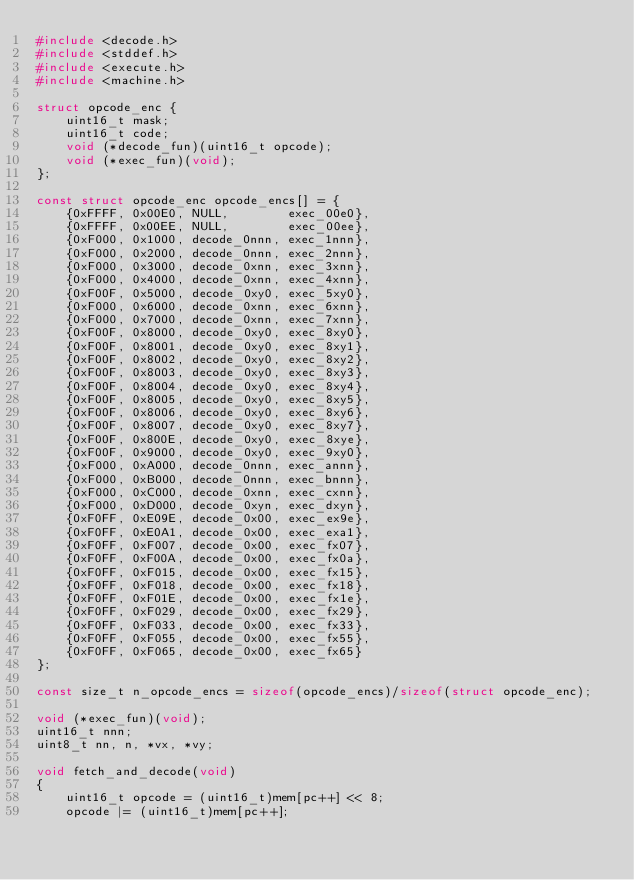<code> <loc_0><loc_0><loc_500><loc_500><_C_>#include <decode.h>
#include <stddef.h>
#include <execute.h>
#include <machine.h>

struct opcode_enc {
    uint16_t mask;
    uint16_t code;
    void (*decode_fun)(uint16_t opcode);
    void (*exec_fun)(void);
};

const struct opcode_enc opcode_encs[] = {
    {0xFFFF, 0x00E0, NULL,        exec_00e0},
    {0xFFFF, 0x00EE, NULL,        exec_00ee},
    {0xF000, 0x1000, decode_0nnn, exec_1nnn},
    {0xF000, 0x2000, decode_0nnn, exec_2nnn},
    {0xF000, 0x3000, decode_0xnn, exec_3xnn},
    {0xF000, 0x4000, decode_0xnn, exec_4xnn},
    {0xF00F, 0x5000, decode_0xy0, exec_5xy0},
    {0xF000, 0x6000, decode_0xnn, exec_6xnn},
    {0xF000, 0x7000, decode_0xnn, exec_7xnn},
    {0xF00F, 0x8000, decode_0xy0, exec_8xy0},
    {0xF00F, 0x8001, decode_0xy0, exec_8xy1},
    {0xF00F, 0x8002, decode_0xy0, exec_8xy2},
    {0xF00F, 0x8003, decode_0xy0, exec_8xy3},
    {0xF00F, 0x8004, decode_0xy0, exec_8xy4},
    {0xF00F, 0x8005, decode_0xy0, exec_8xy5},
    {0xF00F, 0x8006, decode_0xy0, exec_8xy6},
    {0xF00F, 0x8007, decode_0xy0, exec_8xy7},
    {0xF00F, 0x800E, decode_0xy0, exec_8xye},
    {0xF00F, 0x9000, decode_0xy0, exec_9xy0},
    {0xF000, 0xA000, decode_0nnn, exec_annn},
    {0xF000, 0xB000, decode_0nnn, exec_bnnn},
    {0xF000, 0xC000, decode_0xnn, exec_cxnn},
    {0xF000, 0xD000, decode_0xyn, exec_dxyn},
    {0xF0FF, 0xE09E, decode_0x00, exec_ex9e},
    {0xF0FF, 0xE0A1, decode_0x00, exec_exa1},
    {0xF0FF, 0xF007, decode_0x00, exec_fx07},
    {0xF0FF, 0xF00A, decode_0x00, exec_fx0a},
    {0xF0FF, 0xF015, decode_0x00, exec_fx15},
    {0xF0FF, 0xF018, decode_0x00, exec_fx18},
    {0xF0FF, 0xF01E, decode_0x00, exec_fx1e},
    {0xF0FF, 0xF029, decode_0x00, exec_fx29},
    {0xF0FF, 0xF033, decode_0x00, exec_fx33},
    {0xF0FF, 0xF055, decode_0x00, exec_fx55},
    {0xF0FF, 0xF065, decode_0x00, exec_fx65}
};

const size_t n_opcode_encs = sizeof(opcode_encs)/sizeof(struct opcode_enc);

void (*exec_fun)(void);
uint16_t nnn;
uint8_t nn, n, *vx, *vy;

void fetch_and_decode(void)
{
    uint16_t opcode = (uint16_t)mem[pc++] << 8;
    opcode |= (uint16_t)mem[pc++];
</code> 